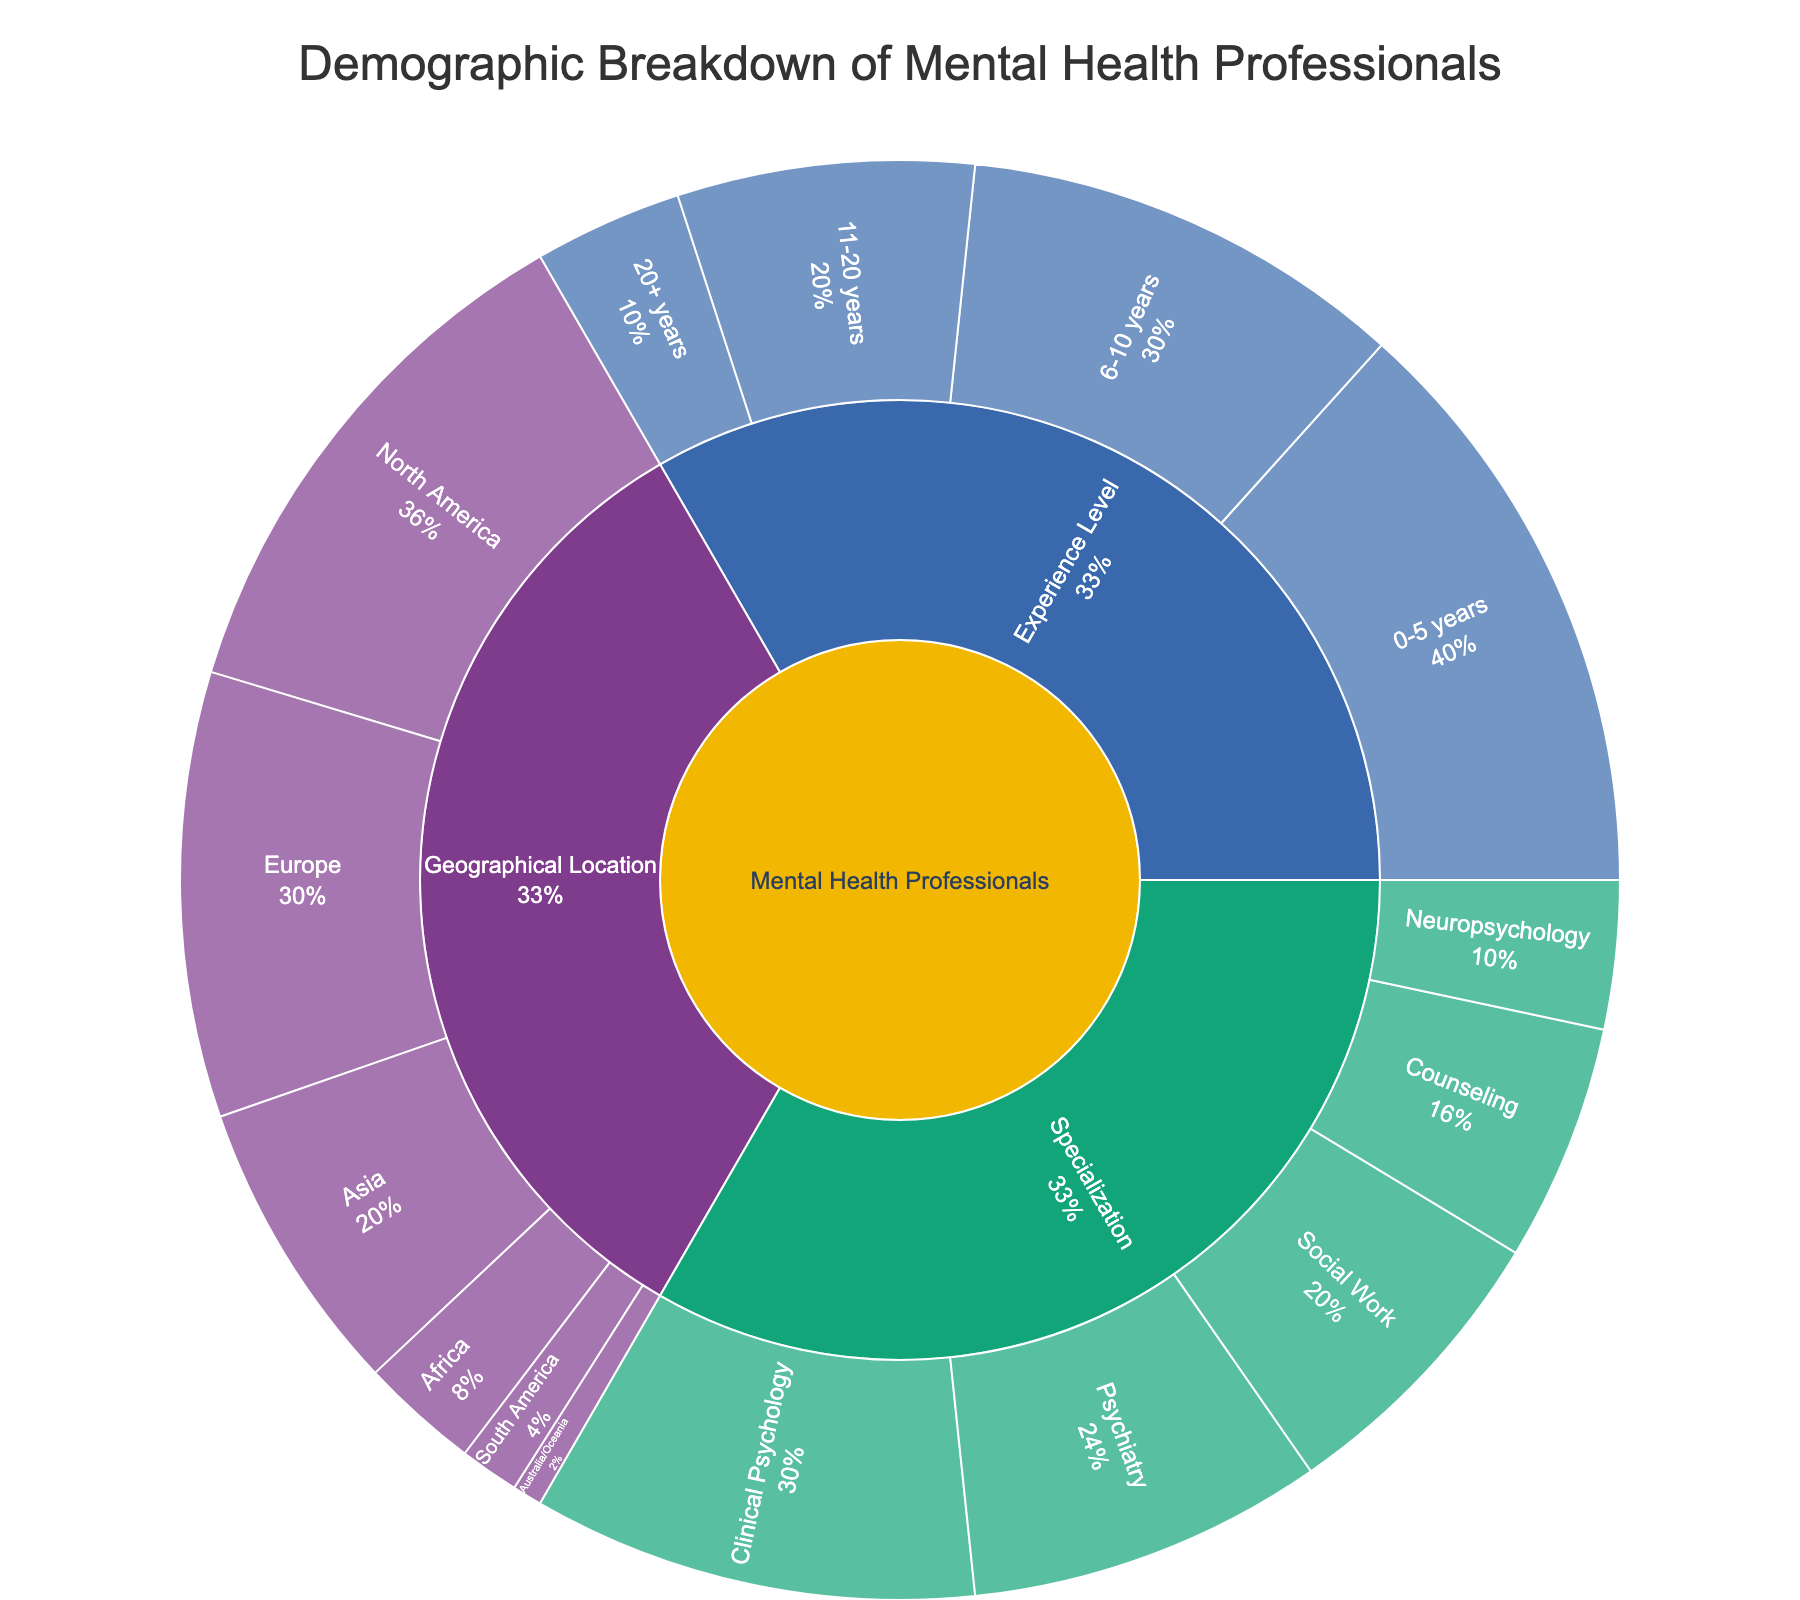What is the title of the figure? The figure's title is crucial as it succinctly describes what the visualization is about. In this case, it indicates that the focus is on the demographics of mental health professionals in a virtual community.
Answer: Demographic Breakdown of Mental Health Professionals Which category has the highest number of mental health professionals? To determine the category with the highest number, we look at the partitions arranged around the central "Mental Health Professionals" node and identify the largest segment based on value.
Answer: Experience Level How many mental health professionals are specialized in Neuropsychology? To find this, we navigate from the root through the specialization category, then look at the specific segment for Neuropsychology.
Answer: 50 What is the total number of mental health professionals with 0-5 years of experience? To answer this, we drill down from the root node through the Experience Level category and identify the value associated with the 0-5 years segment.
Answer: 200 Compare the number of professionals in Clinical Psychology and Psychiatry. Which is greater? This requires locating both the Clinical Psychology and Psychiatry segments under Specialization and comparing their values. Clinical Psychology is 150 and Psychiatry is 120.
Answer: Clinical Psychology How many professionals are there in North America and Europe combined? We find the segments for North America and Europe under the Geographical Location category and sum their values: 180 + 150 = 330.
Answer: 330 What percentage of the professionals are located in Asia out of the total geographical locations? To determine the percentage, we identify Asia's value, sum all geographical categories and calculate: (100 / (180 + 150 + 100 + 40 + 20 + 10)).
Answer: Approximately 20% What is the total number of mental health professionals represented in the figure? To get the total, we sum all the values in the root categories: (150 + 120 + 100 + 80 + 50) + (200 + 150 + 100 + 50) + (180 + 150 + 100 + 40 + 20 + 10).
Answer: 950 Which specialization has fewer professionals than Counseling but more than Neuropsychology? Counseling has 80 and Neuropsychology has 50. We look for a specialization in between these values: Social Work has 100.
Answer: Social Work What is the ratio of professionals with 20+ years of experience to those with 11-20 years? We locate the values for these two segments under Experience Level and form the ratio: 50 (20+ years) to 100 (11-20 years).
Answer: 1:2 